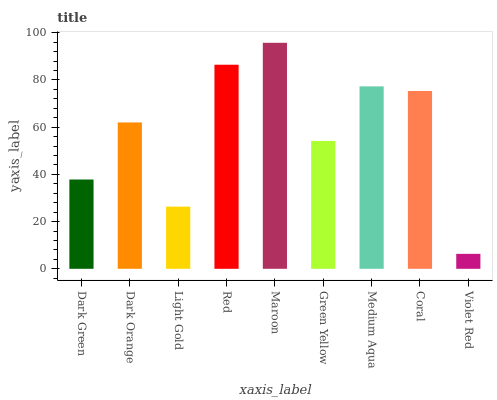Is Violet Red the minimum?
Answer yes or no. Yes. Is Maroon the maximum?
Answer yes or no. Yes. Is Dark Orange the minimum?
Answer yes or no. No. Is Dark Orange the maximum?
Answer yes or no. No. Is Dark Orange greater than Dark Green?
Answer yes or no. Yes. Is Dark Green less than Dark Orange?
Answer yes or no. Yes. Is Dark Green greater than Dark Orange?
Answer yes or no. No. Is Dark Orange less than Dark Green?
Answer yes or no. No. Is Dark Orange the high median?
Answer yes or no. Yes. Is Dark Orange the low median?
Answer yes or no. Yes. Is Coral the high median?
Answer yes or no. No. Is Dark Green the low median?
Answer yes or no. No. 